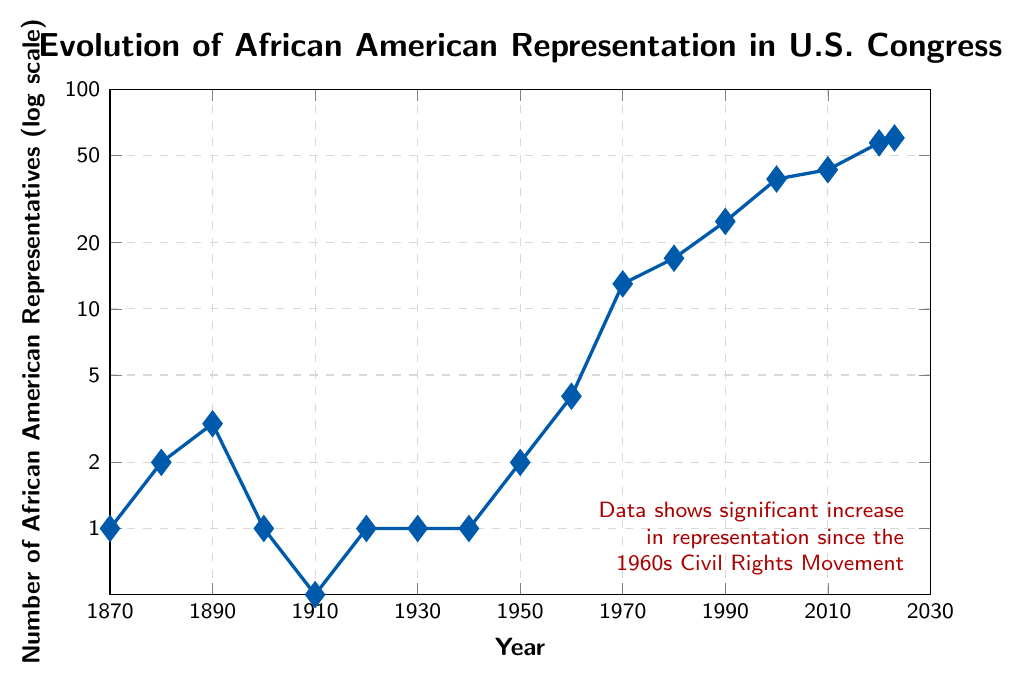What's the earliest year where there was at least one African American representative in U.S. Congress? The plot uses a semilogarithmic scale with the x-axis representing the year and the y-axis representing the number of African American representatives. The earliest data point shows 1 representative in 1870.
Answer: 1870 How many African American representatives were there in 2023 compared to 2000? Read the values for both years from the plot. In 2000, there were 39 representatives, and in 2023, there were 60. Subtract the number in 2000 from the number in 2023: 60 - 39.
Answer: 21 What was the number of African American representatives in 1970 and how did it change by 1980? Read the values from the plot. In 1970, there were 13 representatives. In 1980, there were 17. Compute the difference: 17 - 13.
Answer: 4 In which period did the number of representatives increase the most rapidly? By examining the slope of the plot, the most rapid increase occurred between 1960 and 1970, where the number of representatives increased from 4 to 13.
Answer: 1960-1970 What is notable about the number of African American representatives in the 1910s? The plot shows a significant drop in the number of representatives around this time, to 0, which is distinct from other periods.
Answer: 0 How did the number of African American representatives change from 1870 to 1890? In 1870, there was 1 representative, and by 1890, there were 3. The change is calculated by subtracting the initial value from the final value: 3 - 1.
Answer: 2 What was the percentage increase in the number of African American representatives from 2010 to 2023? In 2010, the number was 43, and in 2023, it was 60. Calculate the percentage increase using the formula ((60-43)/43) * 100%.
Answer: 39.53% Which color is used to highlight the data trend in the plot? The line representing the data is colored in blue, as seen in the plot's visual attributes.
Answer: blue How many years did it take for the number of representatives to remain unchanged at 1? From 1920 to 1940, the number stayed at 1. Calculate the difference between these years: 1940 - 1920.
Answer: 20 What was the trend in the number of African American representatives from 1950 to 2023? From the plot, in 1950, there were 2 representatives; in 2023, this number increased to 60. The consistent upward trend reflects the increase over these years.
Answer: Increasing trend 